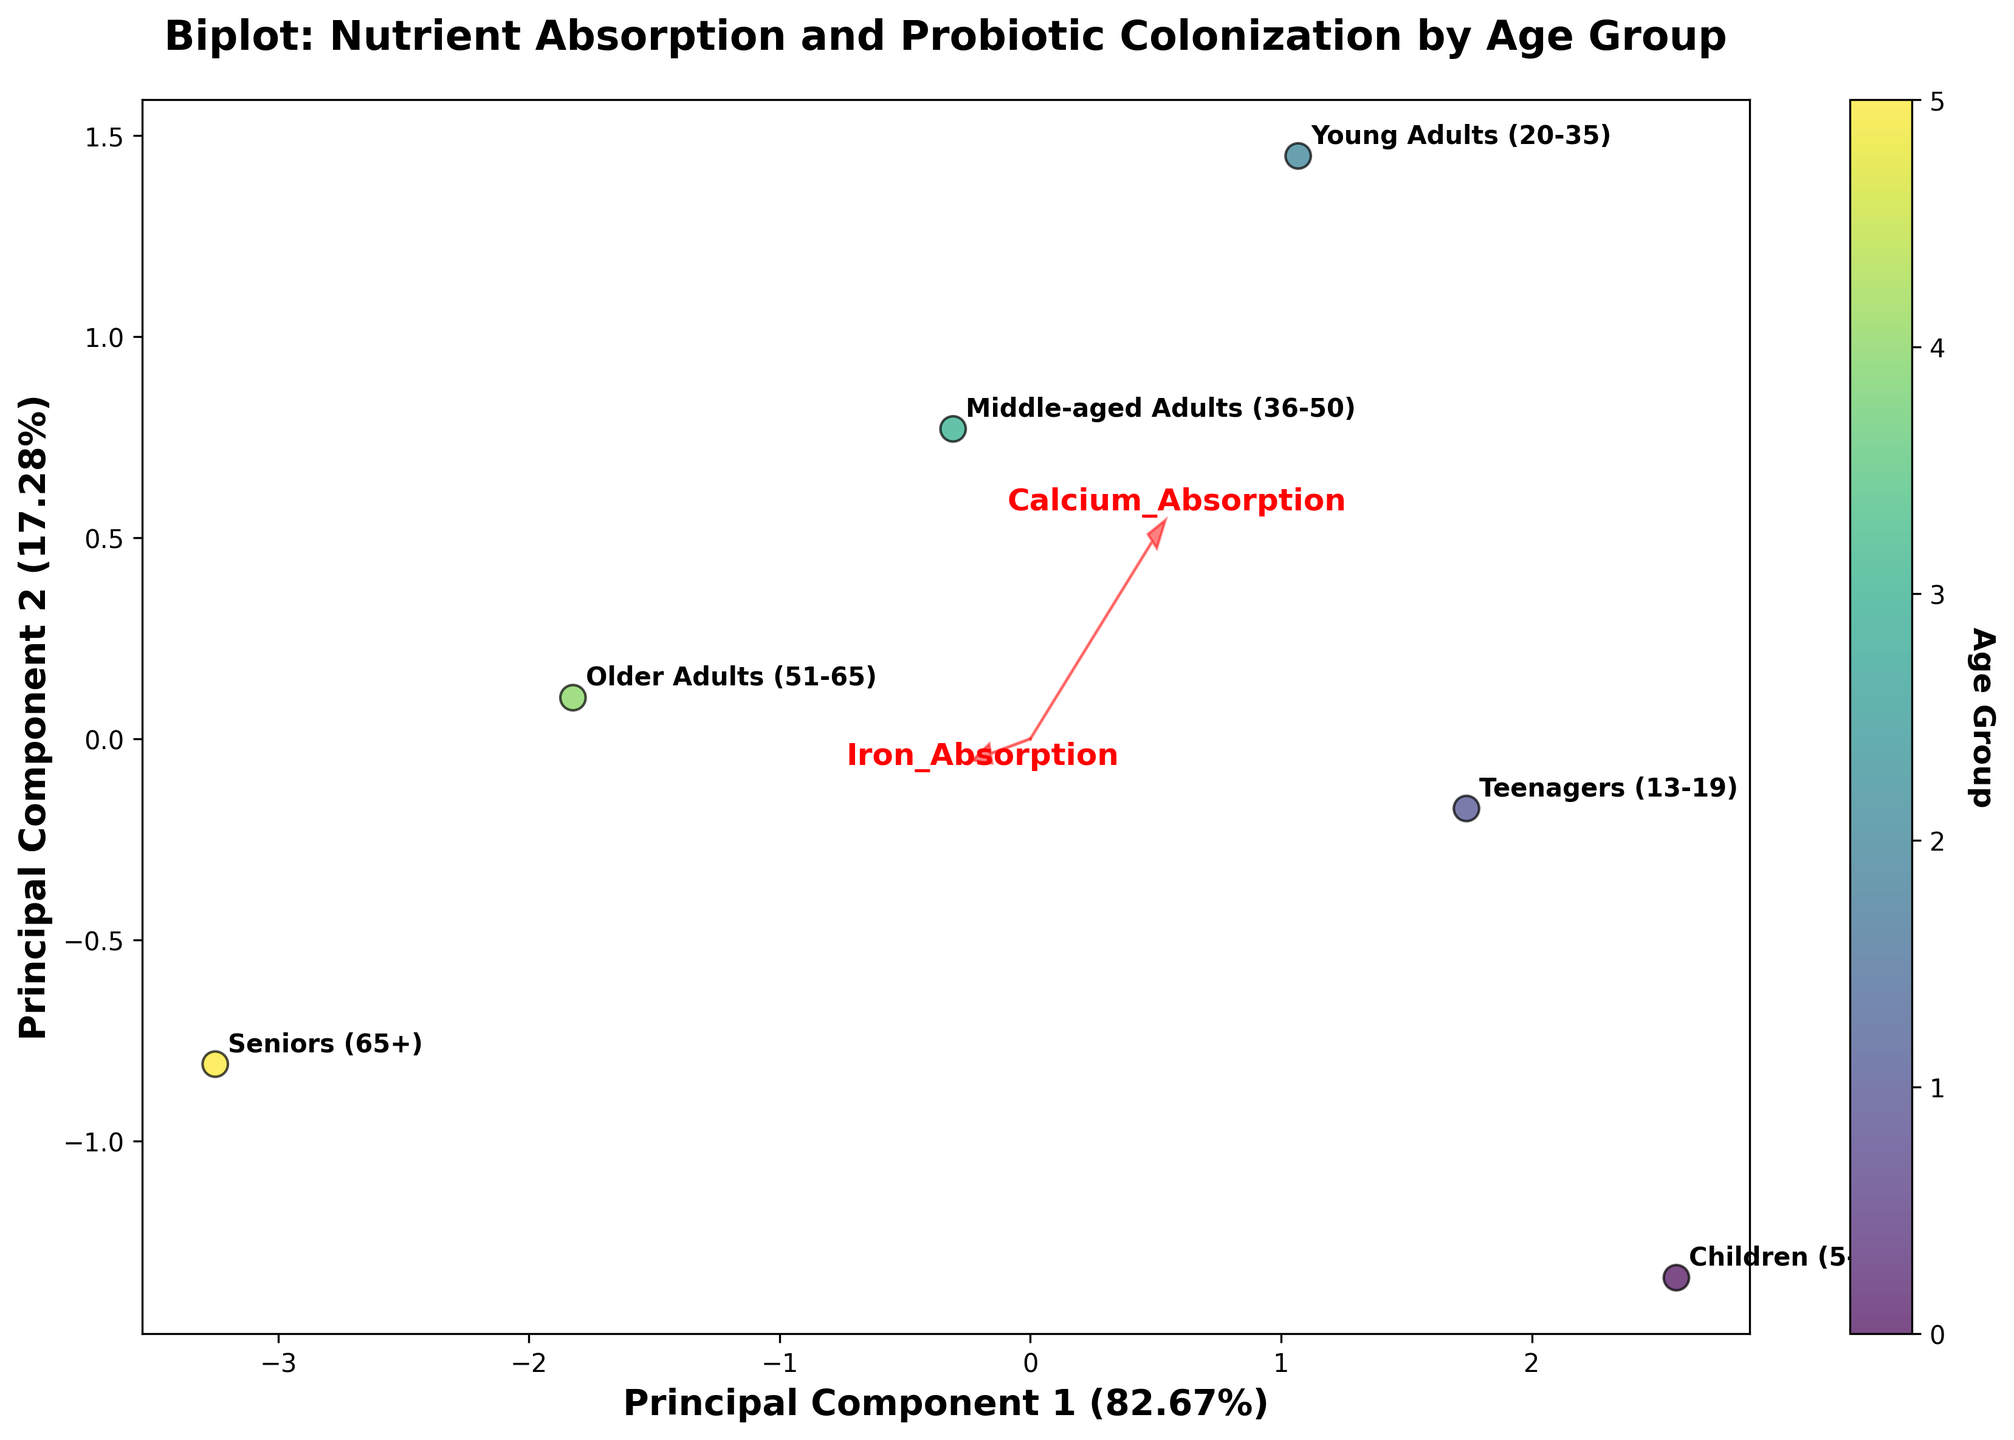What is the title of the plot? The title of the plot is displayed at the top of the figure.
Answer: Biplot: Nutrient Absorption and Probiotic Colonization by Age Group How many age groups are represented in the plot? The number of data points (scatter points) represents the number of age groups. By counting these points, we can determine the number of age groups.
Answer: 6 Which age group has the highest Lactobacillus Colonization rate? The direction and length of the feature vector labeled "Lactobacillus_Colonization" indicate the values. The point closest to this vector's end represents the highest value.
Answer: Young Adults (20-35) How much variance is explained by the first principal component? The percentage of variance explained by the first principal component is indicated on the x-axis label.
Answer: 48.24% Which age group has the lowest Bifidobacterium Colonization rate? The point farthest from the feature vector labeled "Bifidobacterium_Colonization" in the opposite direction represents the lowest value.
Answer: Seniors (65+) What is the relationship between B12 Absorption and Iron Absorption? The angle between the vectors for "B12_Absorption" and "Iron_Absorption" can give insights into their relationship. A small angle indicates a strong positive correlation.
Answer: Positive correlation Which two features are most closely related based on the plot? The two vectors that are the closest to each other in terms of angle signify the highest correlation.
Answer: Calcium Absorption and Iron Absorption Which age group has the lowest value in the first principal component? The data point with the lowest value on the x-axis represents the lowest value in the first principal component.
Answer: Seniors (65+) What is the total Lactobacillus Colonization rate for Teenagers and Middle-aged Adults? Locate the Lactobacillus Colonization coordinate for Teenagers and Middle-aged Adults, then sum the values (72 + 74).
Answer: 146 Which feature appears to have the least variation across the age groups? The shortest feature vector indicates the least variation among age groups.
Answer: Bifidobacterium Colonization 